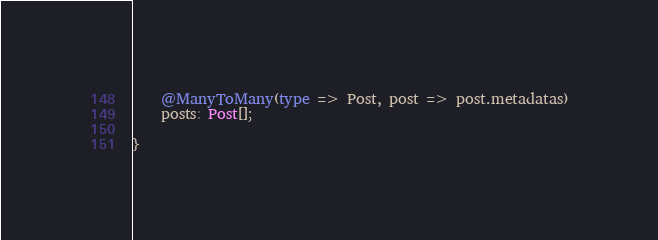Convert code to text. <code><loc_0><loc_0><loc_500><loc_500><_TypeScript_>
    @ManyToMany(type => Post, post => post.metadatas)
    posts: Post[];

}</code> 